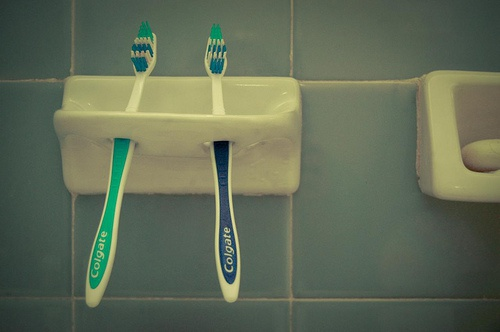Describe the objects in this image and their specific colors. I can see toothbrush in black, green, tan, teal, and khaki tones and toothbrush in black, khaki, blue, tan, and gray tones in this image. 